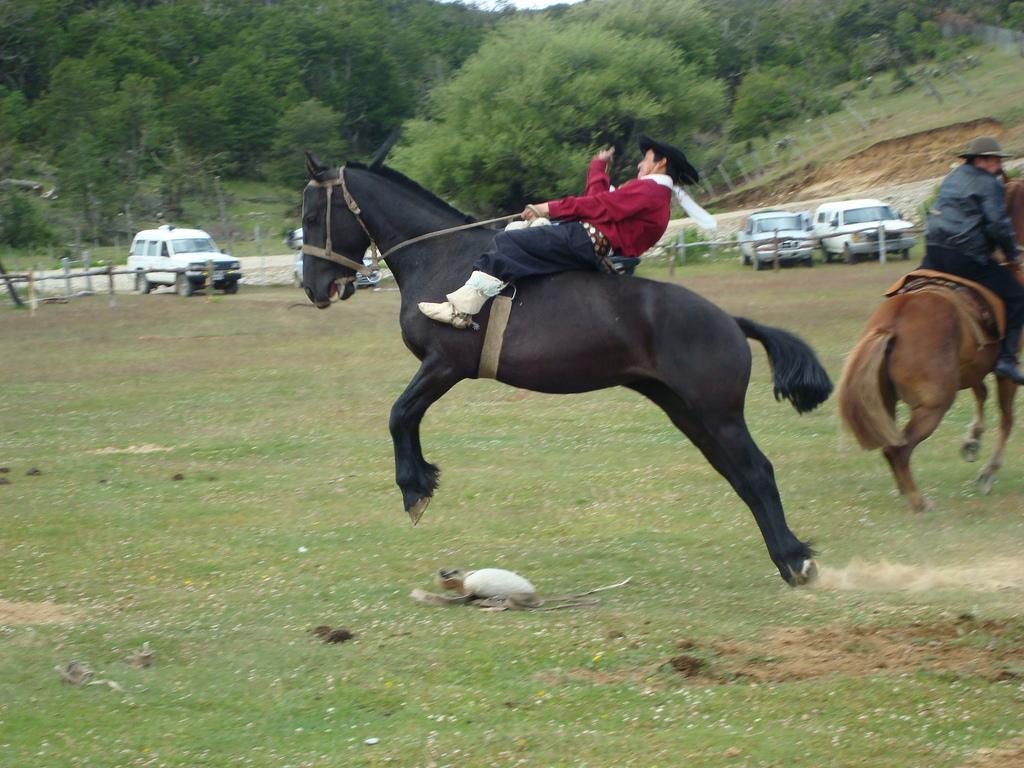In one or two sentences, can you explain what this image depicts? In this image i can see a person wearing a red shirt and black jeans riding a horse, and to the right corner i can see another person sitting on a horse, and in the background i can see some vehicles and trees. 